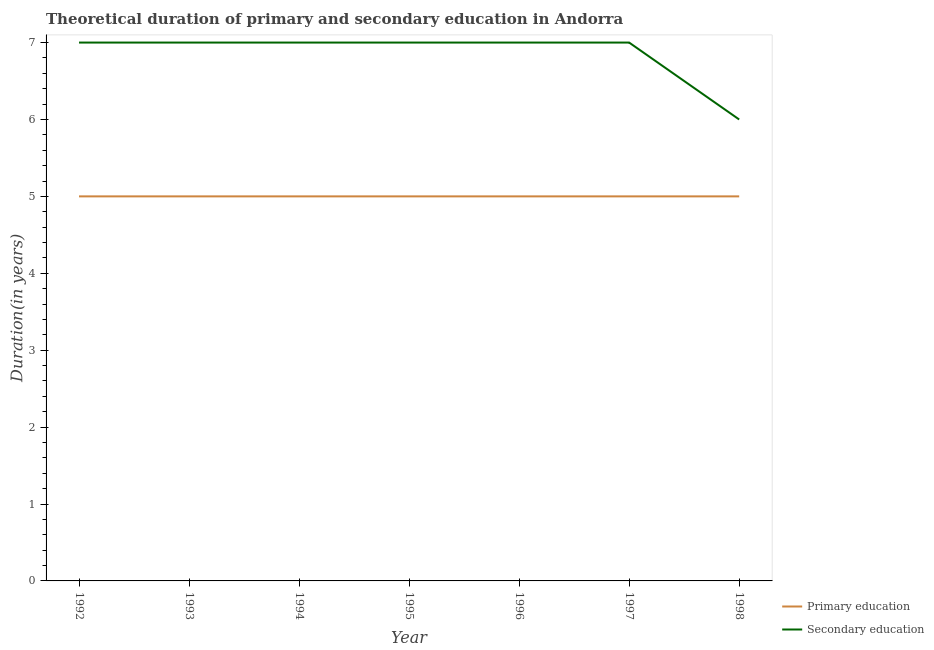How many different coloured lines are there?
Offer a terse response. 2. Does the line corresponding to duration of secondary education intersect with the line corresponding to duration of primary education?
Your answer should be very brief. No. What is the duration of primary education in 1994?
Keep it short and to the point. 5. Across all years, what is the maximum duration of secondary education?
Your response must be concise. 7. Across all years, what is the minimum duration of secondary education?
Keep it short and to the point. 6. What is the total duration of secondary education in the graph?
Offer a very short reply. 48. What is the difference between the duration of primary education in 1995 and the duration of secondary education in 1992?
Your answer should be compact. -2. What is the average duration of primary education per year?
Provide a succinct answer. 5. In the year 1993, what is the difference between the duration of primary education and duration of secondary education?
Offer a very short reply. -2. Is the duration of primary education in 1992 less than that in 1995?
Offer a terse response. No. What is the difference between the highest and the lowest duration of secondary education?
Make the answer very short. 1. Is the sum of the duration of secondary education in 1992 and 1996 greater than the maximum duration of primary education across all years?
Provide a short and direct response. Yes. Does the duration of primary education monotonically increase over the years?
Ensure brevity in your answer.  No. Is the duration of primary education strictly greater than the duration of secondary education over the years?
Your answer should be very brief. No. How many lines are there?
Provide a succinct answer. 2. How many years are there in the graph?
Provide a succinct answer. 7. Are the values on the major ticks of Y-axis written in scientific E-notation?
Make the answer very short. No. Does the graph contain any zero values?
Offer a very short reply. No. Does the graph contain grids?
Your answer should be very brief. No. Where does the legend appear in the graph?
Make the answer very short. Bottom right. How are the legend labels stacked?
Your answer should be very brief. Vertical. What is the title of the graph?
Your answer should be compact. Theoretical duration of primary and secondary education in Andorra. Does "Central government" appear as one of the legend labels in the graph?
Ensure brevity in your answer.  No. What is the label or title of the X-axis?
Keep it short and to the point. Year. What is the label or title of the Y-axis?
Offer a very short reply. Duration(in years). What is the Duration(in years) of Secondary education in 1992?
Ensure brevity in your answer.  7. What is the Duration(in years) in Primary education in 1993?
Your answer should be very brief. 5. What is the Duration(in years) of Secondary education in 1993?
Your response must be concise. 7. What is the Duration(in years) in Secondary education in 1994?
Offer a terse response. 7. What is the Duration(in years) in Primary education in 1995?
Provide a short and direct response. 5. What is the Duration(in years) of Primary education in 1996?
Make the answer very short. 5. What is the Duration(in years) in Primary education in 1997?
Offer a very short reply. 5. What is the Duration(in years) in Secondary education in 1997?
Your answer should be compact. 7. What is the Duration(in years) of Primary education in 1998?
Your answer should be compact. 5. Across all years, what is the maximum Duration(in years) in Primary education?
Offer a terse response. 5. Across all years, what is the maximum Duration(in years) of Secondary education?
Offer a terse response. 7. Across all years, what is the minimum Duration(in years) in Primary education?
Keep it short and to the point. 5. What is the total Duration(in years) in Primary education in the graph?
Your response must be concise. 35. What is the total Duration(in years) in Secondary education in the graph?
Your response must be concise. 48. What is the difference between the Duration(in years) of Primary education in 1992 and that in 1994?
Ensure brevity in your answer.  0. What is the difference between the Duration(in years) in Secondary education in 1992 and that in 1994?
Offer a terse response. 0. What is the difference between the Duration(in years) of Secondary education in 1992 and that in 1995?
Offer a very short reply. 0. What is the difference between the Duration(in years) in Primary education in 1992 and that in 1996?
Offer a terse response. 0. What is the difference between the Duration(in years) of Secondary education in 1992 and that in 1996?
Provide a short and direct response. 0. What is the difference between the Duration(in years) in Primary education in 1992 and that in 1997?
Give a very brief answer. 0. What is the difference between the Duration(in years) in Primary education in 1992 and that in 1998?
Offer a terse response. 0. What is the difference between the Duration(in years) in Secondary education in 1992 and that in 1998?
Your answer should be very brief. 1. What is the difference between the Duration(in years) in Secondary education in 1993 and that in 1994?
Ensure brevity in your answer.  0. What is the difference between the Duration(in years) in Secondary education in 1993 and that in 1995?
Give a very brief answer. 0. What is the difference between the Duration(in years) in Primary education in 1993 and that in 1996?
Ensure brevity in your answer.  0. What is the difference between the Duration(in years) of Secondary education in 1993 and that in 1997?
Keep it short and to the point. 0. What is the difference between the Duration(in years) of Secondary education in 1993 and that in 1998?
Your answer should be compact. 1. What is the difference between the Duration(in years) in Secondary education in 1994 and that in 1995?
Offer a terse response. 0. What is the difference between the Duration(in years) in Primary education in 1994 and that in 1996?
Your response must be concise. 0. What is the difference between the Duration(in years) of Secondary education in 1994 and that in 1996?
Provide a short and direct response. 0. What is the difference between the Duration(in years) in Primary education in 1994 and that in 1997?
Your response must be concise. 0. What is the difference between the Duration(in years) of Secondary education in 1994 and that in 1998?
Offer a very short reply. 1. What is the difference between the Duration(in years) of Secondary education in 1995 and that in 1996?
Give a very brief answer. 0. What is the difference between the Duration(in years) in Secondary education in 1996 and that in 1997?
Your response must be concise. 0. What is the difference between the Duration(in years) in Primary education in 1996 and that in 1998?
Offer a very short reply. 0. What is the difference between the Duration(in years) of Primary education in 1997 and that in 1998?
Your answer should be compact. 0. What is the difference between the Duration(in years) of Primary education in 1992 and the Duration(in years) of Secondary education in 1993?
Your answer should be very brief. -2. What is the difference between the Duration(in years) in Primary education in 1992 and the Duration(in years) in Secondary education in 1995?
Give a very brief answer. -2. What is the difference between the Duration(in years) in Primary education in 1992 and the Duration(in years) in Secondary education in 1998?
Make the answer very short. -1. What is the difference between the Duration(in years) of Primary education in 1993 and the Duration(in years) of Secondary education in 1996?
Offer a terse response. -2. What is the difference between the Duration(in years) of Primary education in 1993 and the Duration(in years) of Secondary education in 1998?
Your response must be concise. -1. What is the difference between the Duration(in years) in Primary education in 1994 and the Duration(in years) in Secondary education in 1995?
Make the answer very short. -2. What is the difference between the Duration(in years) in Primary education in 1994 and the Duration(in years) in Secondary education in 1997?
Provide a short and direct response. -2. What is the difference between the Duration(in years) in Primary education in 1995 and the Duration(in years) in Secondary education in 1996?
Your response must be concise. -2. What is the difference between the Duration(in years) in Primary education in 1995 and the Duration(in years) in Secondary education in 1998?
Give a very brief answer. -1. What is the difference between the Duration(in years) of Primary education in 1996 and the Duration(in years) of Secondary education in 1997?
Your answer should be very brief. -2. What is the difference between the Duration(in years) of Primary education in 1996 and the Duration(in years) of Secondary education in 1998?
Your response must be concise. -1. What is the difference between the Duration(in years) of Primary education in 1997 and the Duration(in years) of Secondary education in 1998?
Provide a succinct answer. -1. What is the average Duration(in years) of Primary education per year?
Provide a short and direct response. 5. What is the average Duration(in years) of Secondary education per year?
Provide a succinct answer. 6.86. In the year 1992, what is the difference between the Duration(in years) of Primary education and Duration(in years) of Secondary education?
Your answer should be compact. -2. In the year 1993, what is the difference between the Duration(in years) of Primary education and Duration(in years) of Secondary education?
Provide a succinct answer. -2. In the year 1994, what is the difference between the Duration(in years) of Primary education and Duration(in years) of Secondary education?
Your answer should be compact. -2. In the year 1995, what is the difference between the Duration(in years) of Primary education and Duration(in years) of Secondary education?
Your answer should be compact. -2. In the year 1997, what is the difference between the Duration(in years) in Primary education and Duration(in years) in Secondary education?
Make the answer very short. -2. In the year 1998, what is the difference between the Duration(in years) in Primary education and Duration(in years) in Secondary education?
Keep it short and to the point. -1. What is the ratio of the Duration(in years) of Primary education in 1992 to that in 1993?
Keep it short and to the point. 1. What is the ratio of the Duration(in years) in Secondary education in 1992 to that in 1993?
Ensure brevity in your answer.  1. What is the ratio of the Duration(in years) of Primary education in 1992 to that in 1994?
Your answer should be very brief. 1. What is the ratio of the Duration(in years) of Secondary education in 1992 to that in 1995?
Keep it short and to the point. 1. What is the ratio of the Duration(in years) in Primary education in 1992 to that in 1996?
Make the answer very short. 1. What is the ratio of the Duration(in years) of Secondary education in 1992 to that in 1997?
Provide a succinct answer. 1. What is the ratio of the Duration(in years) in Primary education in 1992 to that in 1998?
Your answer should be compact. 1. What is the ratio of the Duration(in years) in Secondary education in 1992 to that in 1998?
Ensure brevity in your answer.  1.17. What is the ratio of the Duration(in years) in Secondary education in 1993 to that in 1994?
Your response must be concise. 1. What is the ratio of the Duration(in years) in Primary education in 1993 to that in 1995?
Offer a terse response. 1. What is the ratio of the Duration(in years) in Secondary education in 1993 to that in 1996?
Provide a short and direct response. 1. What is the ratio of the Duration(in years) of Primary education in 1994 to that in 1995?
Offer a very short reply. 1. What is the ratio of the Duration(in years) in Secondary education in 1994 to that in 1995?
Your response must be concise. 1. What is the ratio of the Duration(in years) in Primary education in 1994 to that in 1997?
Offer a terse response. 1. What is the ratio of the Duration(in years) of Primary education in 1994 to that in 1998?
Provide a short and direct response. 1. What is the ratio of the Duration(in years) in Primary education in 1995 to that in 1996?
Your response must be concise. 1. What is the ratio of the Duration(in years) in Secondary education in 1995 to that in 1996?
Keep it short and to the point. 1. What is the ratio of the Duration(in years) of Primary education in 1995 to that in 1997?
Make the answer very short. 1. What is the ratio of the Duration(in years) in Secondary education in 1995 to that in 1997?
Offer a terse response. 1. What is the ratio of the Duration(in years) in Secondary education in 1995 to that in 1998?
Give a very brief answer. 1.17. What is the ratio of the Duration(in years) of Primary education in 1996 to that in 1997?
Ensure brevity in your answer.  1. What is the difference between the highest and the lowest Duration(in years) of Primary education?
Your response must be concise. 0. 